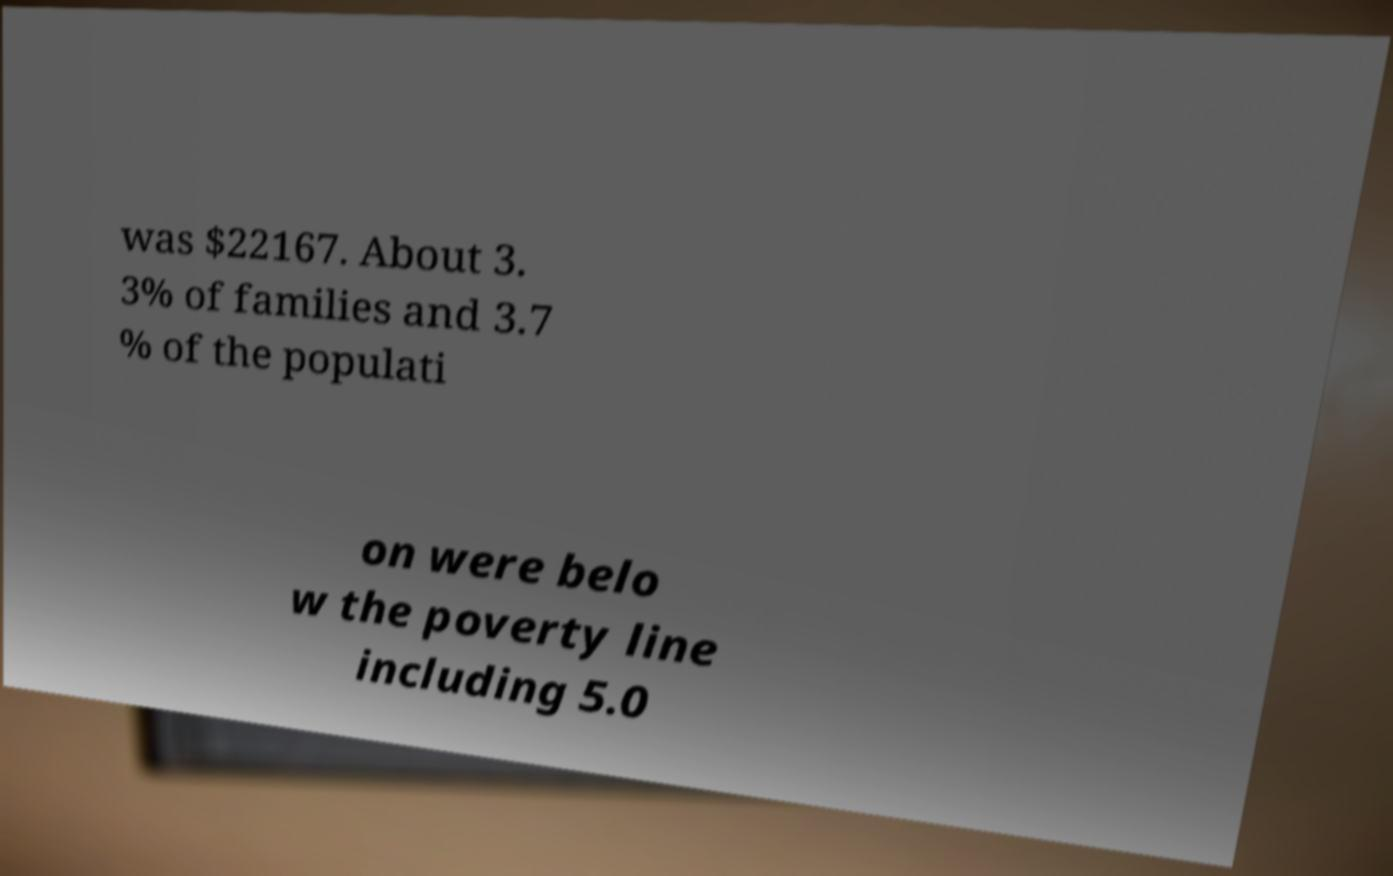There's text embedded in this image that I need extracted. Can you transcribe it verbatim? was $22167. About 3. 3% of families and 3.7 % of the populati on were belo w the poverty line including 5.0 